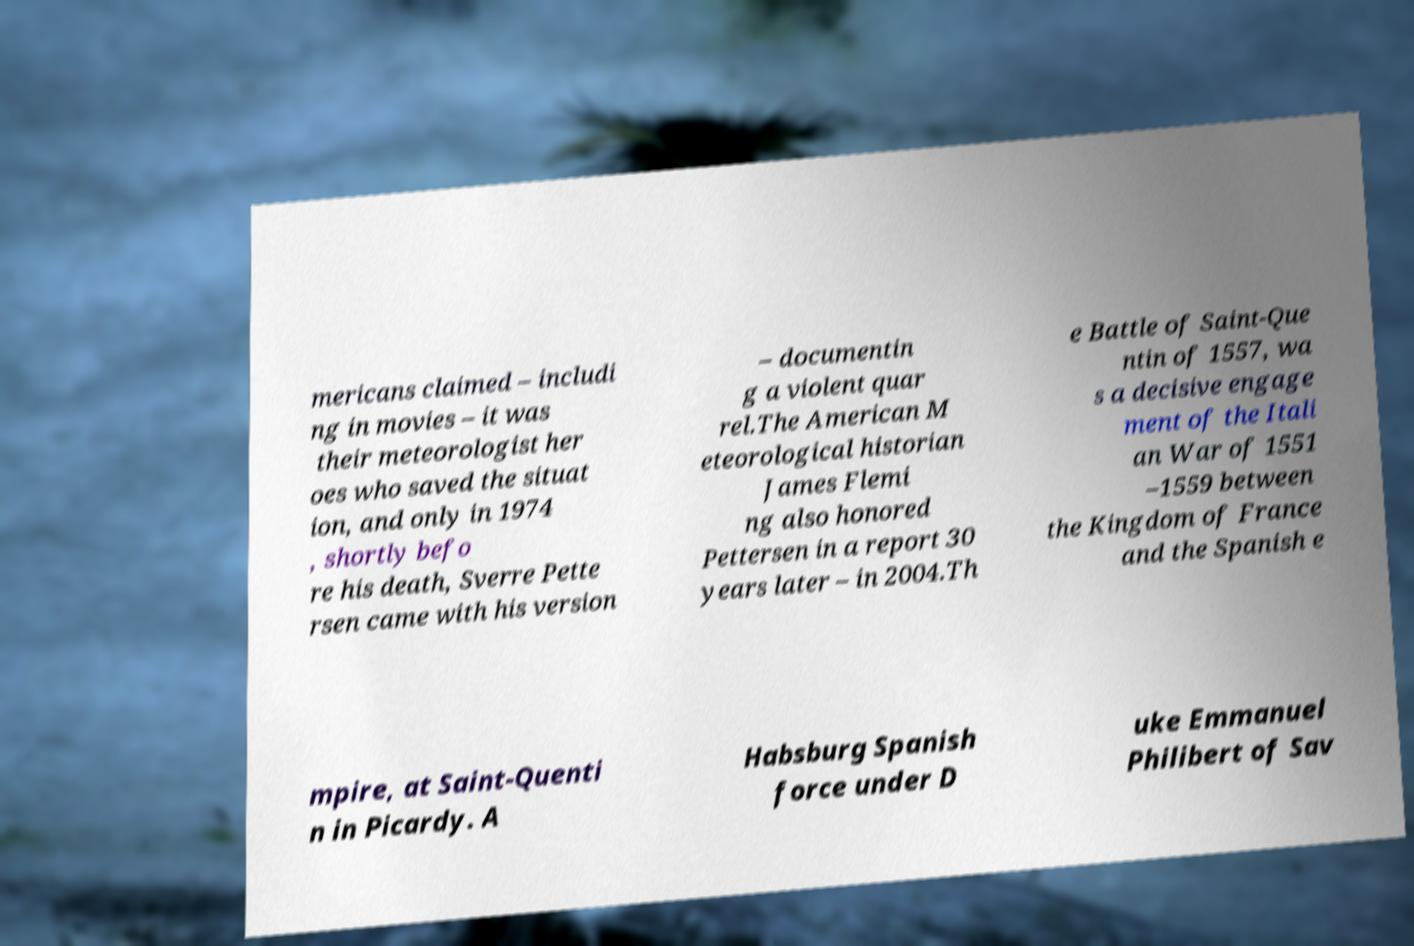Please identify and transcribe the text found in this image. mericans claimed – includi ng in movies – it was their meteorologist her oes who saved the situat ion, and only in 1974 , shortly befo re his death, Sverre Pette rsen came with his version – documentin g a violent quar rel.The American M eteorological historian James Flemi ng also honored Pettersen in a report 30 years later – in 2004.Th e Battle of Saint-Que ntin of 1557, wa s a decisive engage ment of the Itali an War of 1551 –1559 between the Kingdom of France and the Spanish e mpire, at Saint-Quenti n in Picardy. A Habsburg Spanish force under D uke Emmanuel Philibert of Sav 